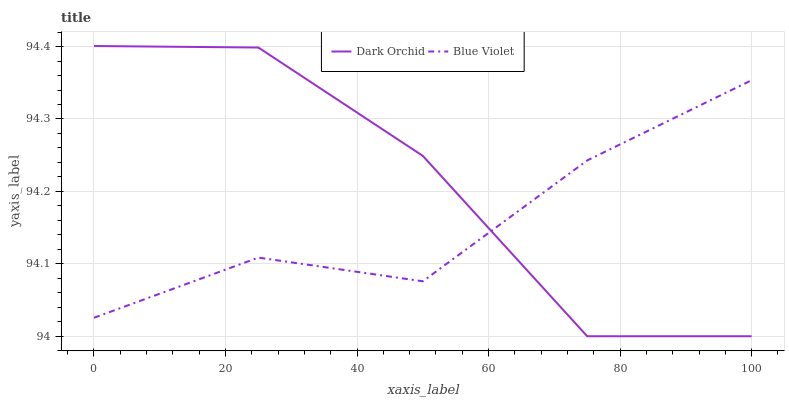Does Dark Orchid have the minimum area under the curve?
Answer yes or no. No. Is Dark Orchid the smoothest?
Answer yes or no. No. 